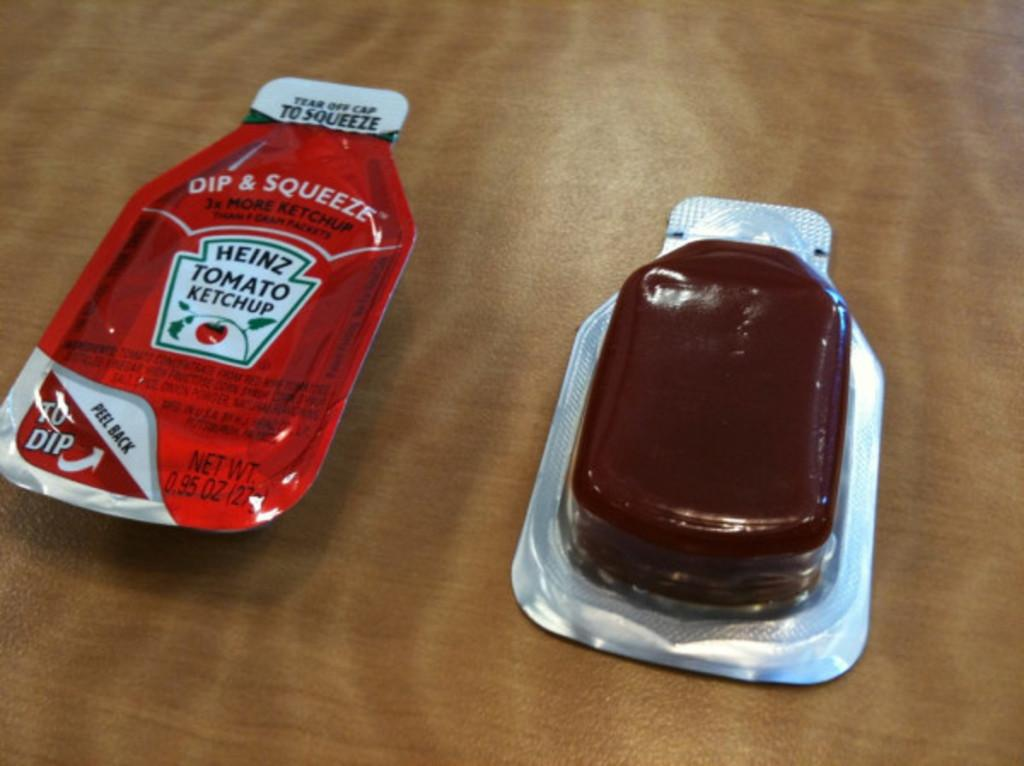<image>
Write a terse but informative summary of the picture. Ketchup type container that says Heinz Tomato Ketchup Dip and Squeeze, 3x more ketchup. 